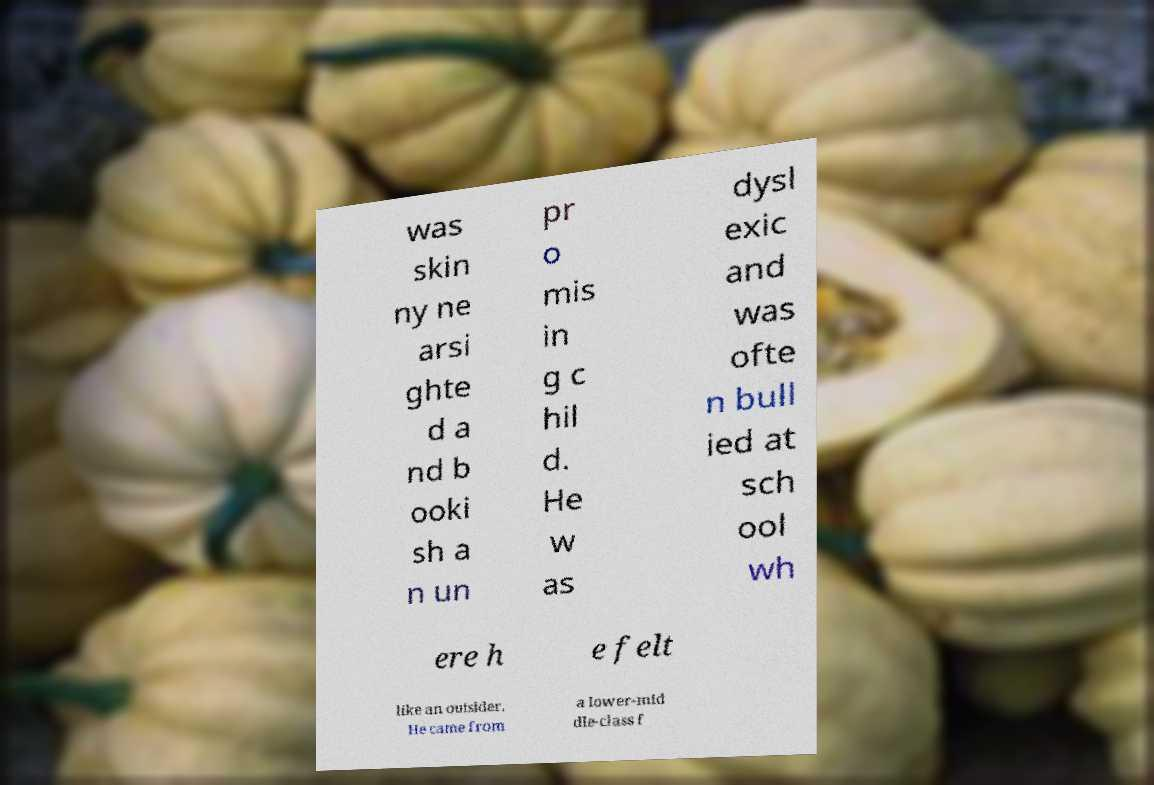For documentation purposes, I need the text within this image transcribed. Could you provide that? was skin ny ne arsi ghte d a nd b ooki sh a n un pr o mis in g c hil d. He w as dysl exic and was ofte n bull ied at sch ool wh ere h e felt like an outsider. He came from a lower-mid dle-class f 